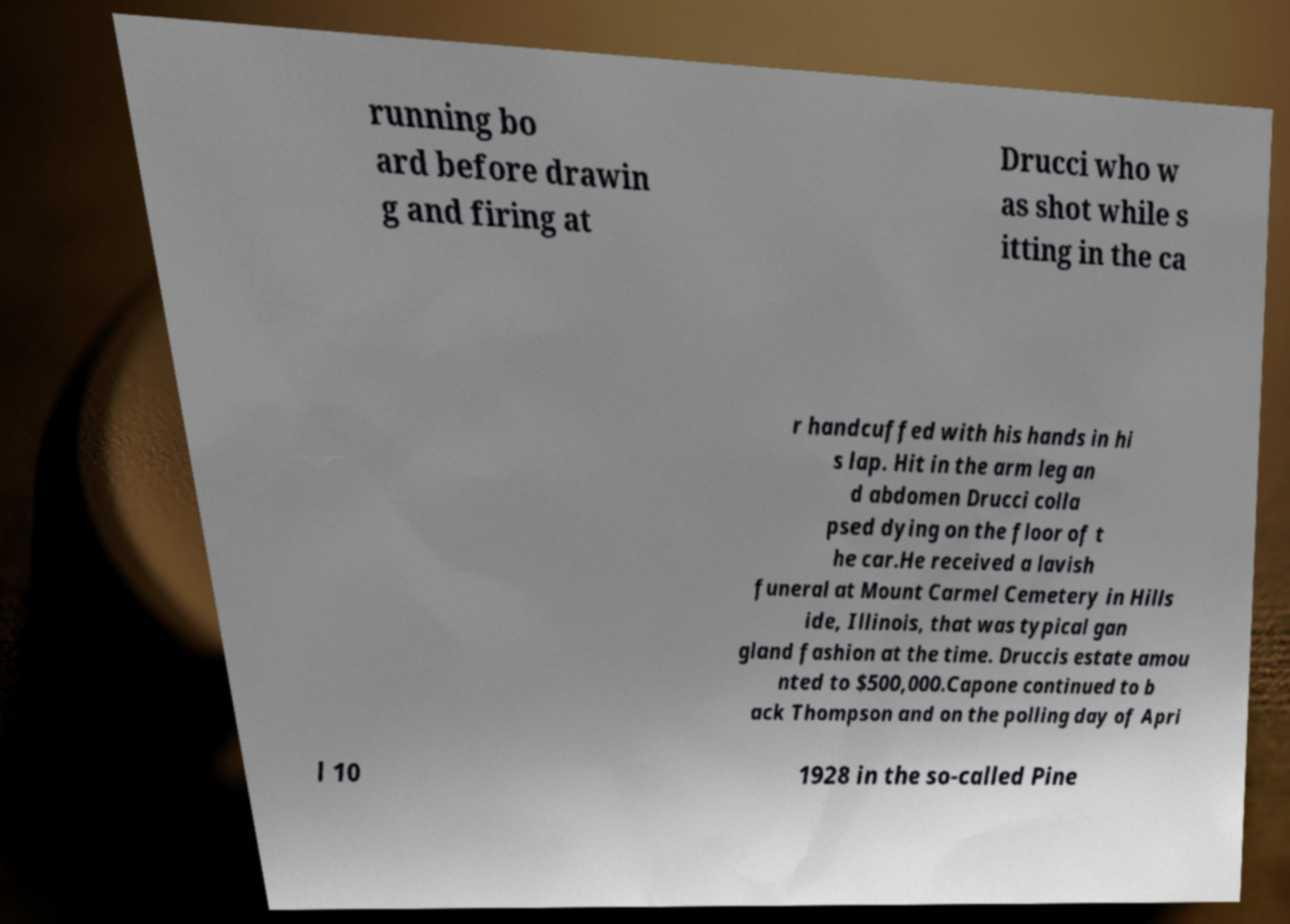Could you assist in decoding the text presented in this image and type it out clearly? running bo ard before drawin g and firing at Drucci who w as shot while s itting in the ca r handcuffed with his hands in hi s lap. Hit in the arm leg an d abdomen Drucci colla psed dying on the floor of t he car.He received a lavish funeral at Mount Carmel Cemetery in Hills ide, Illinois, that was typical gan gland fashion at the time. Druccis estate amou nted to $500,000.Capone continued to b ack Thompson and on the polling day of Apri l 10 1928 in the so-called Pine 